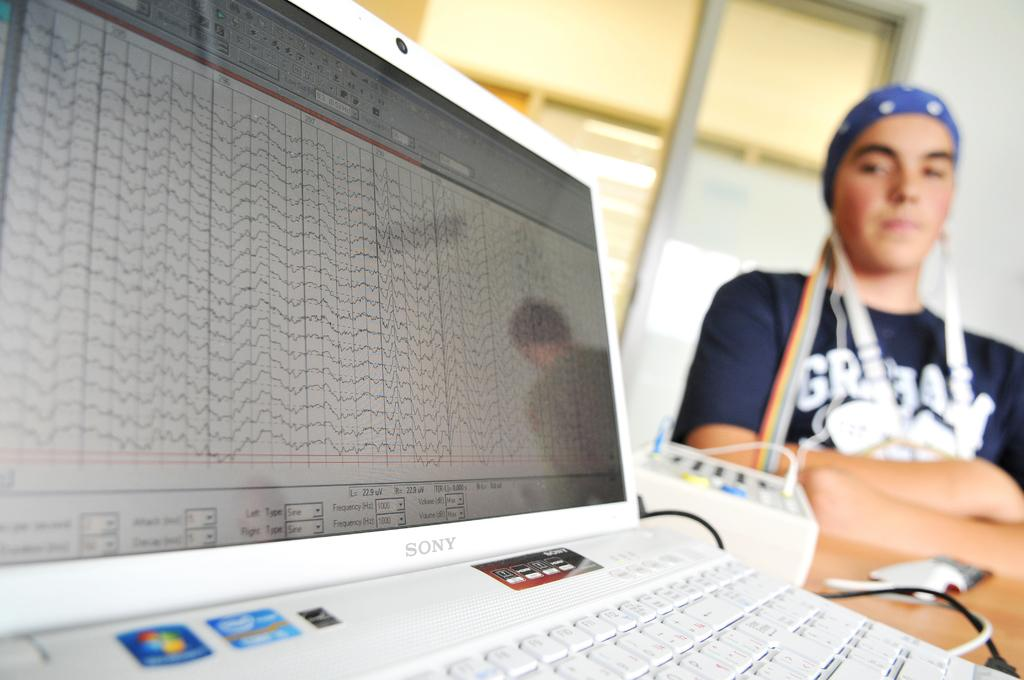What electronic device is visible in the image? There is a white laptop in the image. What is the person in the image doing? The person is looking at the laptop. Where is the person located in the image? The person is on the right side of the image. What type of clothing is the person wearing? The person is wearing a t-shirt. How many teeth does the laptop have in the image? The laptop does not have teeth, as it is an electronic device and not a living organism. 